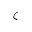Convert formula to latex. <formula><loc_0><loc_0><loc_500><loc_500>\zeta</formula> 